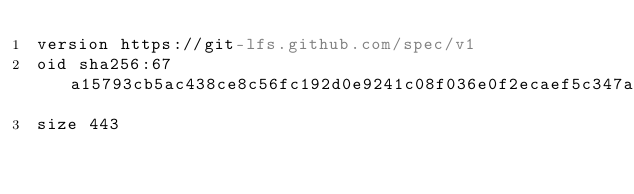Convert code to text. <code><loc_0><loc_0><loc_500><loc_500><_YAML_>version https://git-lfs.github.com/spec/v1
oid sha256:67a15793cb5ac438ce8c56fc192d0e9241c08f036e0f2ecaef5c347a9370cf39
size 443
</code> 